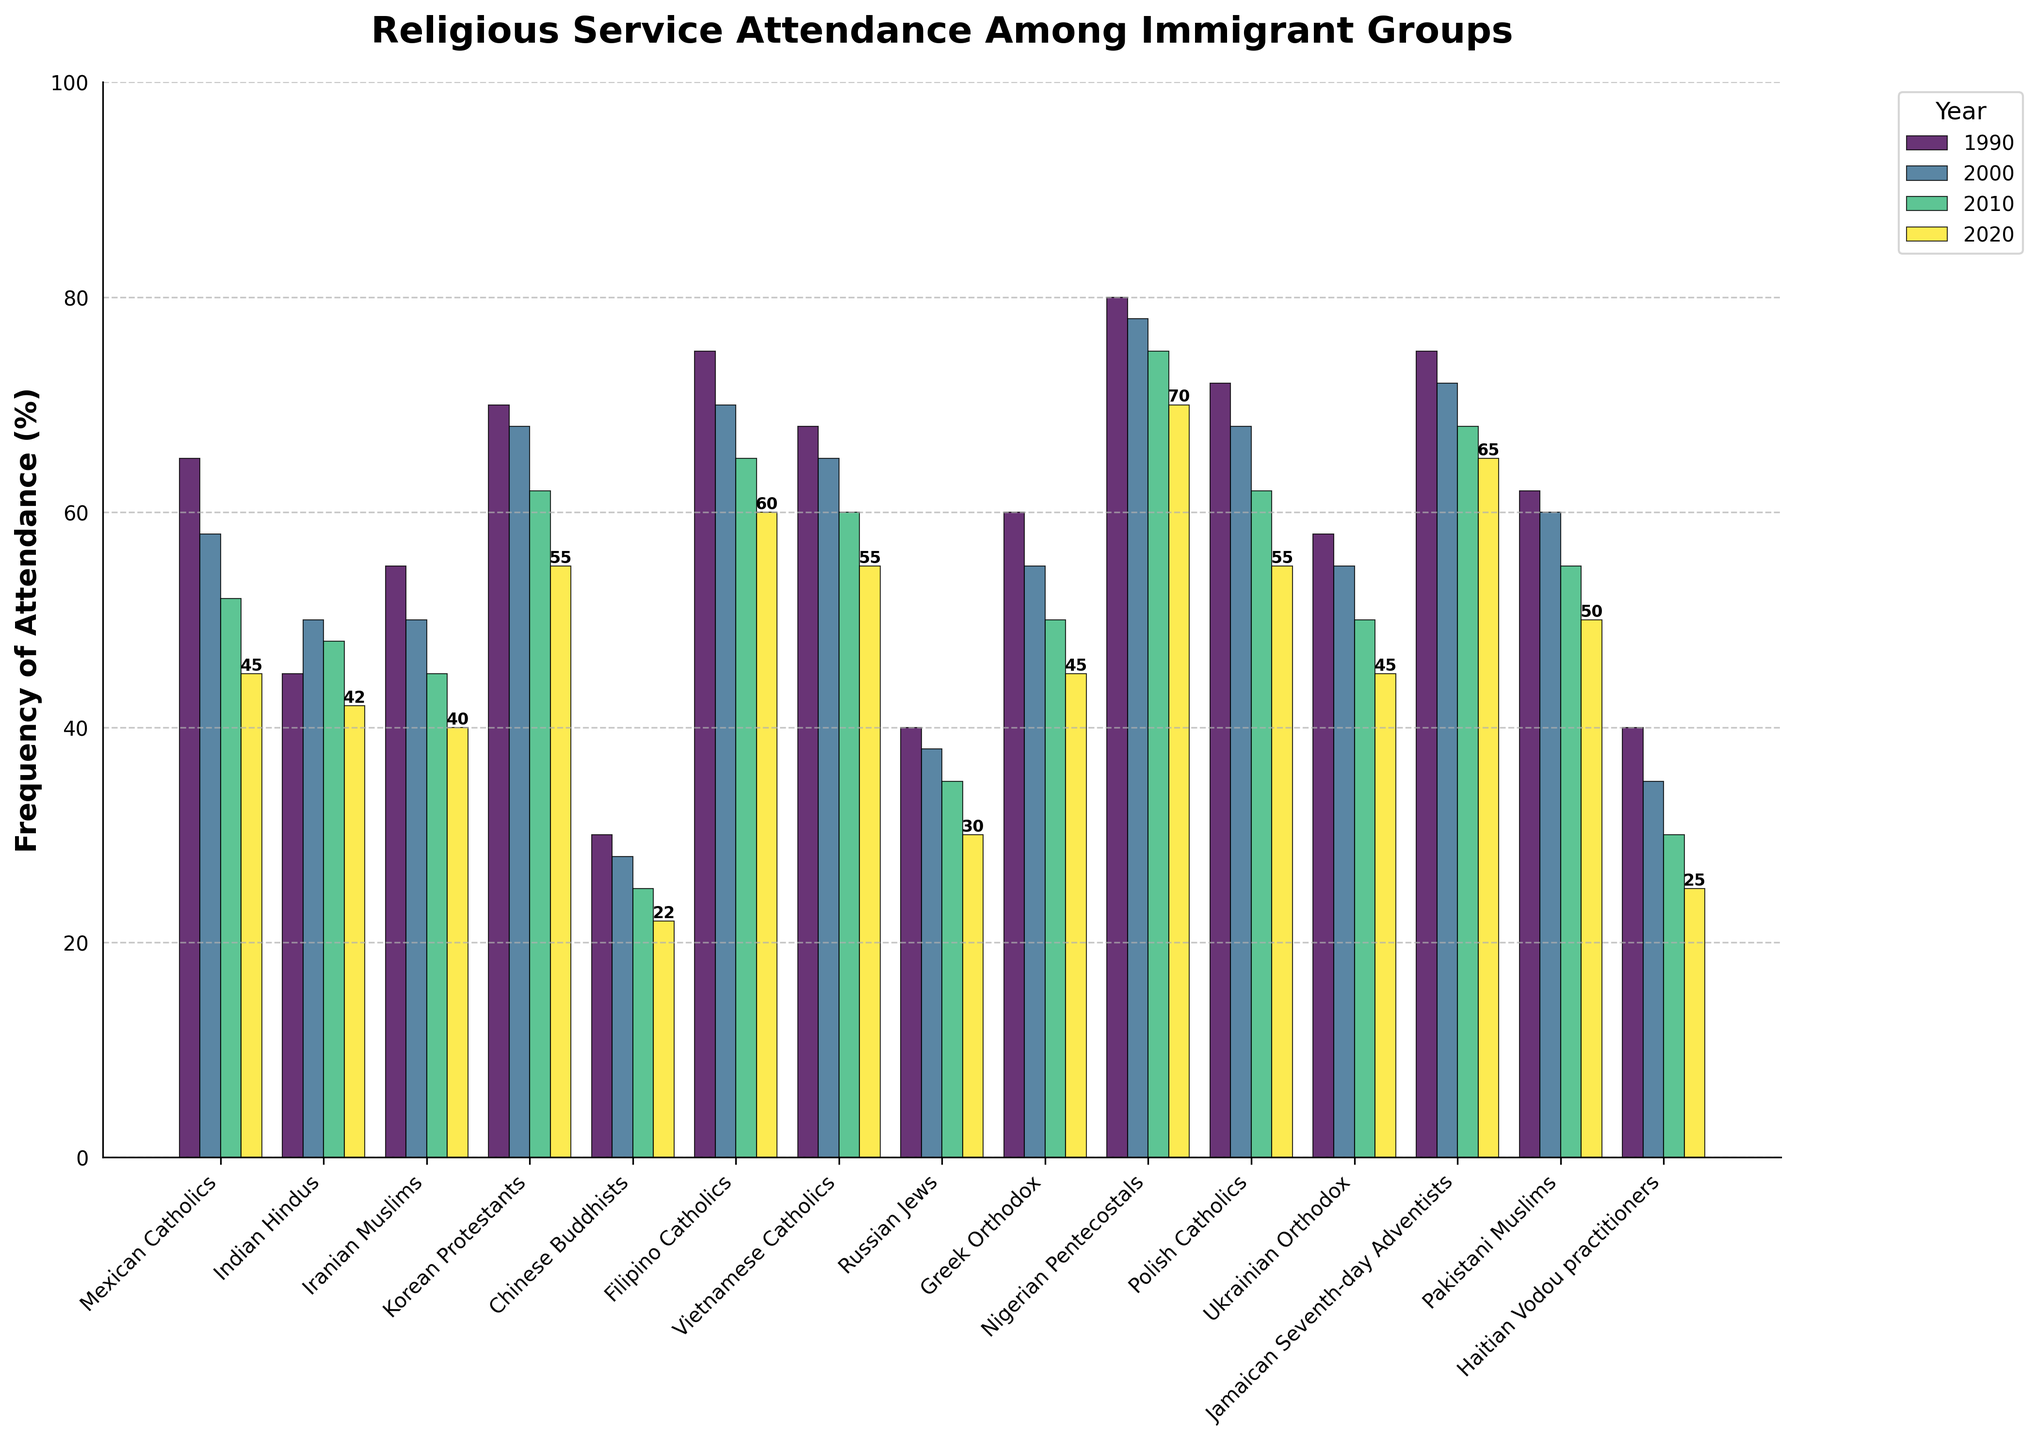Which immigrant group has the highest frequency of attendance in 2020? To find this, examine the bars labeled 2020 and identify the tallest bar.
Answer: Nigerian Pentecostals Which immigrant group showed the largest decrease in attendance from 1990 to 2020? Calculate the decrease for each group by subtracting the 2020 value from the 1990 value. The group with the largest decrease is the answer.
Answer: Mexican Catholics What is the average attendance rate of Indian Hindus over the years 1990, 2000, 2010, and 2020? Sum the values for Indian Hindus (45+50+48+42) and divide by the number of years, which is 4. (45+50+48+42)/4 = 185/4
Answer: 46.25 How does the attendance frequency of Korean Protestants in 2020 compare to Filipino Catholics in the same year? Find the bar heights for both groups in 2020 and compare them. Korean Protestants (55) and Filipino Catholics (60), Filipino Catholics have a higher attendance.
Answer: Filipino Catholics higher Which immigrant group has the smallest variation in attendance frequency across the years? Calculate the range of attendance frequency for each group by subtracting the smallest value from the largest value and identify the group with the smallest range. For Greek Orthodox: max is 60, min is 45, range is 15. Repeat for others and compare.
Answer: Greek Orthodox What is the change in attendance frequency for Pakistani Muslims from 2000 to 2010? Subtract the attendance value of Pakistani Muslims in 2000 from their value in 2010. 55 - 60 = -5
Answer: -5 Among Russian Jews and Haitian Vodou practitioners, which group had a higher attendance rate in 2010? Compare the bars of Russian Jews (35) and Haitian Vodou practitioners (30) for the year 2010.
Answer: Russian Jews Which years are represented in the chart? Look at the legend or the x-axis to determine which years are plotted as bars.
Answer: 1990, 2000, 2010, 2020 How much did the attendance of Chinese Buddhists decrease from 1990 to 2020? Subtract the 2020 value for Chinese Buddhists from the 1990 value. 30 - 22 = 8
Answer: 8 Comparing the attendance frequency in 2020, is there a group with the same attendance rate? Look at the 2020 values for each group to see if any two groups have the same height in their bars. Ukrainian Orthodox and Greek Orthodox both have a value of 45.
Answer: Yes (Ukrainian Orthodox, Greek Orthodox) 